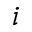<formula> <loc_0><loc_0><loc_500><loc_500>_ { i }</formula> 